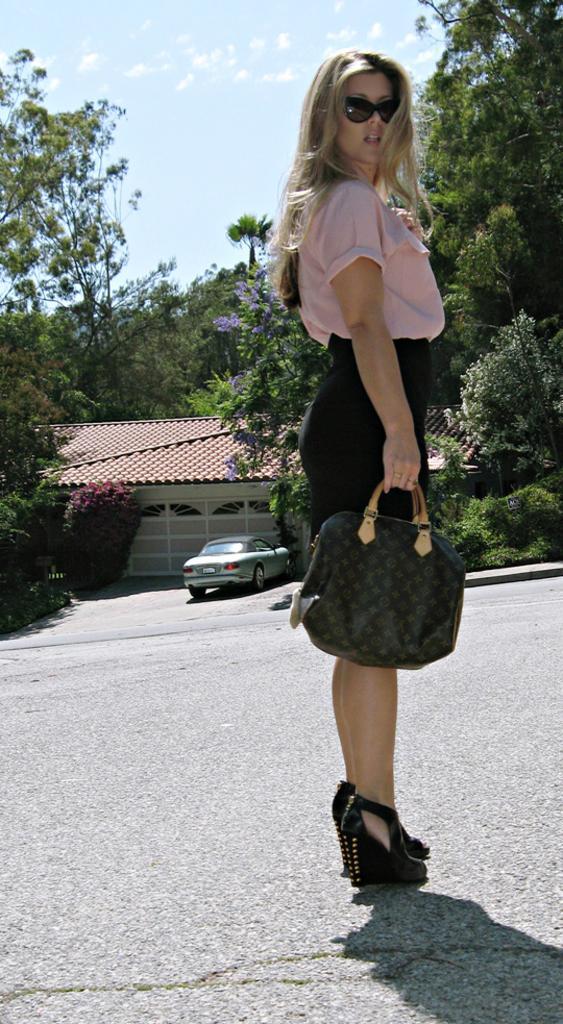Could you give a brief overview of what you see in this image? In the image we can see one woman standing and holding handbag. In the background there is a sky,clouds,trees,house,plant and car. 